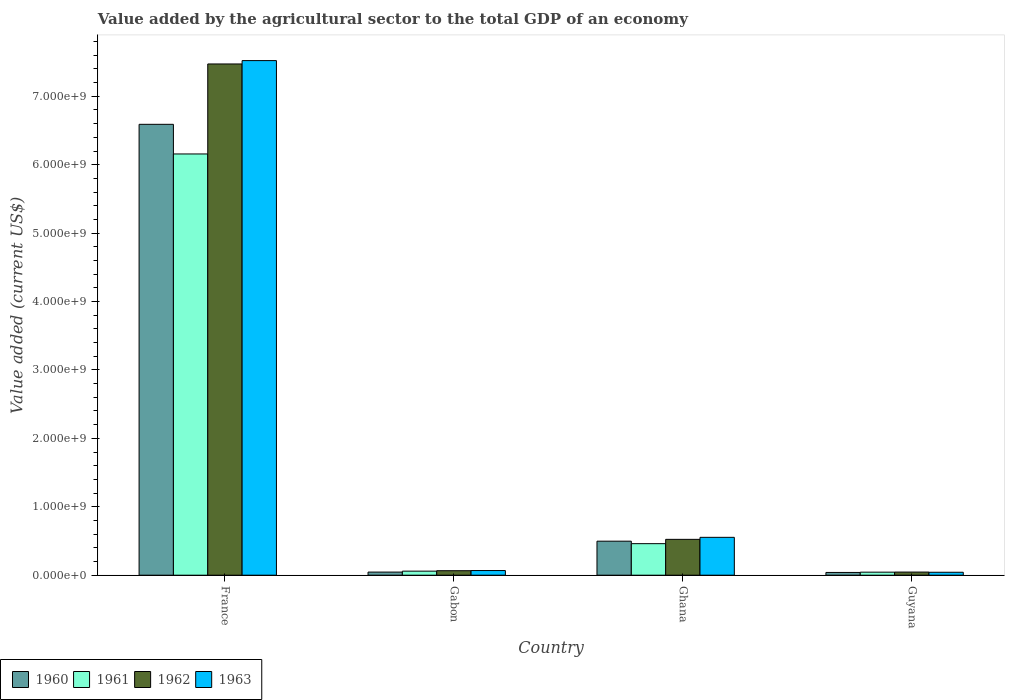Are the number of bars on each tick of the X-axis equal?
Offer a terse response. Yes. How many bars are there on the 3rd tick from the left?
Offer a terse response. 4. What is the label of the 2nd group of bars from the left?
Your answer should be very brief. Gabon. What is the value added by the agricultural sector to the total GDP in 1961 in Gabon?
Ensure brevity in your answer.  5.90e+07. Across all countries, what is the maximum value added by the agricultural sector to the total GDP in 1960?
Your response must be concise. 6.59e+09. Across all countries, what is the minimum value added by the agricultural sector to the total GDP in 1962?
Your response must be concise. 4.57e+07. In which country was the value added by the agricultural sector to the total GDP in 1961 maximum?
Your response must be concise. France. In which country was the value added by the agricultural sector to the total GDP in 1963 minimum?
Your response must be concise. Guyana. What is the total value added by the agricultural sector to the total GDP in 1960 in the graph?
Provide a short and direct response. 7.17e+09. What is the difference between the value added by the agricultural sector to the total GDP in 1961 in France and that in Guyana?
Offer a terse response. 6.11e+09. What is the difference between the value added by the agricultural sector to the total GDP in 1960 in France and the value added by the agricultural sector to the total GDP in 1963 in Ghana?
Offer a very short reply. 6.04e+09. What is the average value added by the agricultural sector to the total GDP in 1961 per country?
Your answer should be compact. 1.68e+09. What is the difference between the value added by the agricultural sector to the total GDP of/in 1962 and value added by the agricultural sector to the total GDP of/in 1960 in Gabon?
Your answer should be very brief. 2.01e+07. What is the ratio of the value added by the agricultural sector to the total GDP in 1961 in France to that in Ghana?
Provide a succinct answer. 13.36. What is the difference between the highest and the second highest value added by the agricultural sector to the total GDP in 1961?
Offer a terse response. 6.10e+09. What is the difference between the highest and the lowest value added by the agricultural sector to the total GDP in 1962?
Ensure brevity in your answer.  7.43e+09. Is the sum of the value added by the agricultural sector to the total GDP in 1961 in Ghana and Guyana greater than the maximum value added by the agricultural sector to the total GDP in 1960 across all countries?
Your answer should be very brief. No. Is it the case that in every country, the sum of the value added by the agricultural sector to the total GDP in 1961 and value added by the agricultural sector to the total GDP in 1963 is greater than the sum of value added by the agricultural sector to the total GDP in 1960 and value added by the agricultural sector to the total GDP in 1962?
Make the answer very short. No. What does the 3rd bar from the right in Gabon represents?
Ensure brevity in your answer.  1961. Is it the case that in every country, the sum of the value added by the agricultural sector to the total GDP in 1962 and value added by the agricultural sector to the total GDP in 1961 is greater than the value added by the agricultural sector to the total GDP in 1963?
Your response must be concise. Yes. How many countries are there in the graph?
Offer a terse response. 4. What is the difference between two consecutive major ticks on the Y-axis?
Your answer should be very brief. 1.00e+09. Does the graph contain grids?
Provide a short and direct response. No. Where does the legend appear in the graph?
Give a very brief answer. Bottom left. How many legend labels are there?
Your response must be concise. 4. What is the title of the graph?
Ensure brevity in your answer.  Value added by the agricultural sector to the total GDP of an economy. Does "2004" appear as one of the legend labels in the graph?
Give a very brief answer. No. What is the label or title of the X-axis?
Provide a short and direct response. Country. What is the label or title of the Y-axis?
Keep it short and to the point. Value added (current US$). What is the Value added (current US$) in 1960 in France?
Your response must be concise. 6.59e+09. What is the Value added (current US$) in 1961 in France?
Keep it short and to the point. 6.16e+09. What is the Value added (current US$) in 1962 in France?
Give a very brief answer. 7.47e+09. What is the Value added (current US$) of 1963 in France?
Offer a very short reply. 7.52e+09. What is the Value added (current US$) of 1960 in Gabon?
Your answer should be very brief. 4.55e+07. What is the Value added (current US$) of 1961 in Gabon?
Make the answer very short. 5.90e+07. What is the Value added (current US$) of 1962 in Gabon?
Your answer should be very brief. 6.56e+07. What is the Value added (current US$) of 1963 in Gabon?
Give a very brief answer. 6.81e+07. What is the Value added (current US$) in 1960 in Ghana?
Ensure brevity in your answer.  4.97e+08. What is the Value added (current US$) of 1961 in Ghana?
Keep it short and to the point. 4.61e+08. What is the Value added (current US$) in 1962 in Ghana?
Provide a short and direct response. 5.24e+08. What is the Value added (current US$) in 1963 in Ghana?
Your answer should be compact. 5.53e+08. What is the Value added (current US$) of 1960 in Guyana?
Offer a terse response. 4.01e+07. What is the Value added (current US$) of 1961 in Guyana?
Provide a short and direct response. 4.43e+07. What is the Value added (current US$) of 1962 in Guyana?
Your answer should be compact. 4.57e+07. What is the Value added (current US$) in 1963 in Guyana?
Provide a succinct answer. 4.30e+07. Across all countries, what is the maximum Value added (current US$) in 1960?
Give a very brief answer. 6.59e+09. Across all countries, what is the maximum Value added (current US$) of 1961?
Your answer should be very brief. 6.16e+09. Across all countries, what is the maximum Value added (current US$) in 1962?
Your answer should be very brief. 7.47e+09. Across all countries, what is the maximum Value added (current US$) in 1963?
Your answer should be compact. 7.52e+09. Across all countries, what is the minimum Value added (current US$) of 1960?
Your answer should be very brief. 4.01e+07. Across all countries, what is the minimum Value added (current US$) of 1961?
Offer a terse response. 4.43e+07. Across all countries, what is the minimum Value added (current US$) of 1962?
Provide a succinct answer. 4.57e+07. Across all countries, what is the minimum Value added (current US$) in 1963?
Your response must be concise. 4.30e+07. What is the total Value added (current US$) of 1960 in the graph?
Keep it short and to the point. 7.17e+09. What is the total Value added (current US$) in 1961 in the graph?
Your response must be concise. 6.72e+09. What is the total Value added (current US$) in 1962 in the graph?
Provide a short and direct response. 8.11e+09. What is the total Value added (current US$) of 1963 in the graph?
Offer a terse response. 8.19e+09. What is the difference between the Value added (current US$) of 1960 in France and that in Gabon?
Your answer should be compact. 6.54e+09. What is the difference between the Value added (current US$) in 1961 in France and that in Gabon?
Your answer should be compact. 6.10e+09. What is the difference between the Value added (current US$) in 1962 in France and that in Gabon?
Provide a short and direct response. 7.41e+09. What is the difference between the Value added (current US$) of 1963 in France and that in Gabon?
Provide a short and direct response. 7.45e+09. What is the difference between the Value added (current US$) of 1960 in France and that in Ghana?
Give a very brief answer. 6.09e+09. What is the difference between the Value added (current US$) in 1961 in France and that in Ghana?
Keep it short and to the point. 5.70e+09. What is the difference between the Value added (current US$) in 1962 in France and that in Ghana?
Ensure brevity in your answer.  6.95e+09. What is the difference between the Value added (current US$) of 1963 in France and that in Ghana?
Give a very brief answer. 6.97e+09. What is the difference between the Value added (current US$) in 1960 in France and that in Guyana?
Ensure brevity in your answer.  6.55e+09. What is the difference between the Value added (current US$) in 1961 in France and that in Guyana?
Make the answer very short. 6.11e+09. What is the difference between the Value added (current US$) of 1962 in France and that in Guyana?
Your answer should be compact. 7.43e+09. What is the difference between the Value added (current US$) of 1963 in France and that in Guyana?
Provide a succinct answer. 7.48e+09. What is the difference between the Value added (current US$) in 1960 in Gabon and that in Ghana?
Provide a succinct answer. -4.52e+08. What is the difference between the Value added (current US$) of 1961 in Gabon and that in Ghana?
Provide a succinct answer. -4.02e+08. What is the difference between the Value added (current US$) of 1962 in Gabon and that in Ghana?
Provide a succinct answer. -4.58e+08. What is the difference between the Value added (current US$) of 1963 in Gabon and that in Ghana?
Provide a succinct answer. -4.85e+08. What is the difference between the Value added (current US$) in 1960 in Gabon and that in Guyana?
Make the answer very short. 5.40e+06. What is the difference between the Value added (current US$) of 1961 in Gabon and that in Guyana?
Keep it short and to the point. 1.47e+07. What is the difference between the Value added (current US$) in 1962 in Gabon and that in Guyana?
Offer a very short reply. 1.99e+07. What is the difference between the Value added (current US$) in 1963 in Gabon and that in Guyana?
Ensure brevity in your answer.  2.51e+07. What is the difference between the Value added (current US$) in 1960 in Ghana and that in Guyana?
Offer a terse response. 4.57e+08. What is the difference between the Value added (current US$) of 1961 in Ghana and that in Guyana?
Give a very brief answer. 4.17e+08. What is the difference between the Value added (current US$) in 1962 in Ghana and that in Guyana?
Offer a very short reply. 4.78e+08. What is the difference between the Value added (current US$) in 1963 in Ghana and that in Guyana?
Keep it short and to the point. 5.10e+08. What is the difference between the Value added (current US$) of 1960 in France and the Value added (current US$) of 1961 in Gabon?
Offer a very short reply. 6.53e+09. What is the difference between the Value added (current US$) in 1960 in France and the Value added (current US$) in 1962 in Gabon?
Your answer should be compact. 6.52e+09. What is the difference between the Value added (current US$) in 1960 in France and the Value added (current US$) in 1963 in Gabon?
Provide a succinct answer. 6.52e+09. What is the difference between the Value added (current US$) of 1961 in France and the Value added (current US$) of 1962 in Gabon?
Give a very brief answer. 6.09e+09. What is the difference between the Value added (current US$) of 1961 in France and the Value added (current US$) of 1963 in Gabon?
Your response must be concise. 6.09e+09. What is the difference between the Value added (current US$) of 1962 in France and the Value added (current US$) of 1963 in Gabon?
Your answer should be very brief. 7.40e+09. What is the difference between the Value added (current US$) of 1960 in France and the Value added (current US$) of 1961 in Ghana?
Give a very brief answer. 6.13e+09. What is the difference between the Value added (current US$) of 1960 in France and the Value added (current US$) of 1962 in Ghana?
Keep it short and to the point. 6.07e+09. What is the difference between the Value added (current US$) of 1960 in France and the Value added (current US$) of 1963 in Ghana?
Your answer should be compact. 6.04e+09. What is the difference between the Value added (current US$) in 1961 in France and the Value added (current US$) in 1962 in Ghana?
Your response must be concise. 5.63e+09. What is the difference between the Value added (current US$) of 1961 in France and the Value added (current US$) of 1963 in Ghana?
Make the answer very short. 5.60e+09. What is the difference between the Value added (current US$) of 1962 in France and the Value added (current US$) of 1963 in Ghana?
Keep it short and to the point. 6.92e+09. What is the difference between the Value added (current US$) in 1960 in France and the Value added (current US$) in 1961 in Guyana?
Give a very brief answer. 6.55e+09. What is the difference between the Value added (current US$) of 1960 in France and the Value added (current US$) of 1962 in Guyana?
Provide a succinct answer. 6.54e+09. What is the difference between the Value added (current US$) in 1960 in France and the Value added (current US$) in 1963 in Guyana?
Your answer should be compact. 6.55e+09. What is the difference between the Value added (current US$) of 1961 in France and the Value added (current US$) of 1962 in Guyana?
Keep it short and to the point. 6.11e+09. What is the difference between the Value added (current US$) in 1961 in France and the Value added (current US$) in 1963 in Guyana?
Your answer should be compact. 6.11e+09. What is the difference between the Value added (current US$) in 1962 in France and the Value added (current US$) in 1963 in Guyana?
Keep it short and to the point. 7.43e+09. What is the difference between the Value added (current US$) of 1960 in Gabon and the Value added (current US$) of 1961 in Ghana?
Give a very brief answer. -4.15e+08. What is the difference between the Value added (current US$) of 1960 in Gabon and the Value added (current US$) of 1962 in Ghana?
Offer a terse response. -4.78e+08. What is the difference between the Value added (current US$) in 1960 in Gabon and the Value added (current US$) in 1963 in Ghana?
Make the answer very short. -5.08e+08. What is the difference between the Value added (current US$) of 1961 in Gabon and the Value added (current US$) of 1962 in Ghana?
Your answer should be very brief. -4.65e+08. What is the difference between the Value added (current US$) of 1961 in Gabon and the Value added (current US$) of 1963 in Ghana?
Provide a short and direct response. -4.94e+08. What is the difference between the Value added (current US$) in 1962 in Gabon and the Value added (current US$) in 1963 in Ghana?
Offer a very short reply. -4.88e+08. What is the difference between the Value added (current US$) of 1960 in Gabon and the Value added (current US$) of 1961 in Guyana?
Ensure brevity in your answer.  1.20e+06. What is the difference between the Value added (current US$) of 1960 in Gabon and the Value added (current US$) of 1962 in Guyana?
Give a very brief answer. -1.99e+05. What is the difference between the Value added (current US$) in 1960 in Gabon and the Value added (current US$) in 1963 in Guyana?
Offer a terse response. 2.54e+06. What is the difference between the Value added (current US$) in 1961 in Gabon and the Value added (current US$) in 1962 in Guyana?
Offer a terse response. 1.33e+07. What is the difference between the Value added (current US$) in 1961 in Gabon and the Value added (current US$) in 1963 in Guyana?
Your answer should be very brief. 1.60e+07. What is the difference between the Value added (current US$) in 1962 in Gabon and the Value added (current US$) in 1963 in Guyana?
Your answer should be compact. 2.26e+07. What is the difference between the Value added (current US$) in 1960 in Ghana and the Value added (current US$) in 1961 in Guyana?
Give a very brief answer. 4.53e+08. What is the difference between the Value added (current US$) in 1960 in Ghana and the Value added (current US$) in 1962 in Guyana?
Your response must be concise. 4.52e+08. What is the difference between the Value added (current US$) of 1960 in Ghana and the Value added (current US$) of 1963 in Guyana?
Give a very brief answer. 4.54e+08. What is the difference between the Value added (current US$) of 1961 in Ghana and the Value added (current US$) of 1962 in Guyana?
Your response must be concise. 4.15e+08. What is the difference between the Value added (current US$) of 1961 in Ghana and the Value added (current US$) of 1963 in Guyana?
Your answer should be compact. 4.18e+08. What is the difference between the Value added (current US$) in 1962 in Ghana and the Value added (current US$) in 1963 in Guyana?
Keep it short and to the point. 4.81e+08. What is the average Value added (current US$) of 1960 per country?
Your answer should be very brief. 1.79e+09. What is the average Value added (current US$) in 1961 per country?
Ensure brevity in your answer.  1.68e+09. What is the average Value added (current US$) of 1962 per country?
Your response must be concise. 2.03e+09. What is the average Value added (current US$) in 1963 per country?
Offer a very short reply. 2.05e+09. What is the difference between the Value added (current US$) of 1960 and Value added (current US$) of 1961 in France?
Your answer should be very brief. 4.33e+08. What is the difference between the Value added (current US$) in 1960 and Value added (current US$) in 1962 in France?
Keep it short and to the point. -8.82e+08. What is the difference between the Value added (current US$) in 1960 and Value added (current US$) in 1963 in France?
Your answer should be very brief. -9.31e+08. What is the difference between the Value added (current US$) of 1961 and Value added (current US$) of 1962 in France?
Give a very brief answer. -1.32e+09. What is the difference between the Value added (current US$) in 1961 and Value added (current US$) in 1963 in France?
Your answer should be compact. -1.36e+09. What is the difference between the Value added (current US$) of 1962 and Value added (current US$) of 1963 in France?
Your answer should be very brief. -4.92e+07. What is the difference between the Value added (current US$) of 1960 and Value added (current US$) of 1961 in Gabon?
Ensure brevity in your answer.  -1.35e+07. What is the difference between the Value added (current US$) in 1960 and Value added (current US$) in 1962 in Gabon?
Your answer should be compact. -2.01e+07. What is the difference between the Value added (current US$) of 1960 and Value added (current US$) of 1963 in Gabon?
Provide a succinct answer. -2.26e+07. What is the difference between the Value added (current US$) of 1961 and Value added (current US$) of 1962 in Gabon?
Your answer should be very brief. -6.57e+06. What is the difference between the Value added (current US$) in 1961 and Value added (current US$) in 1963 in Gabon?
Give a very brief answer. -9.07e+06. What is the difference between the Value added (current US$) in 1962 and Value added (current US$) in 1963 in Gabon?
Make the answer very short. -2.50e+06. What is the difference between the Value added (current US$) of 1960 and Value added (current US$) of 1961 in Ghana?
Your answer should be very brief. 3.64e+07. What is the difference between the Value added (current US$) of 1960 and Value added (current US$) of 1962 in Ghana?
Give a very brief answer. -2.66e+07. What is the difference between the Value added (current US$) in 1960 and Value added (current US$) in 1963 in Ghana?
Offer a very short reply. -5.60e+07. What is the difference between the Value added (current US$) in 1961 and Value added (current US$) in 1962 in Ghana?
Ensure brevity in your answer.  -6.30e+07. What is the difference between the Value added (current US$) of 1961 and Value added (current US$) of 1963 in Ghana?
Offer a terse response. -9.24e+07. What is the difference between the Value added (current US$) in 1962 and Value added (current US$) in 1963 in Ghana?
Provide a short and direct response. -2.94e+07. What is the difference between the Value added (current US$) of 1960 and Value added (current US$) of 1961 in Guyana?
Ensure brevity in your answer.  -4.20e+06. What is the difference between the Value added (current US$) in 1960 and Value added (current US$) in 1962 in Guyana?
Keep it short and to the point. -5.60e+06. What is the difference between the Value added (current US$) in 1960 and Value added (current US$) in 1963 in Guyana?
Your answer should be compact. -2.86e+06. What is the difference between the Value added (current US$) of 1961 and Value added (current US$) of 1962 in Guyana?
Make the answer very short. -1.40e+06. What is the difference between the Value added (current US$) in 1961 and Value added (current US$) in 1963 in Guyana?
Offer a terse response. 1.34e+06. What is the difference between the Value added (current US$) in 1962 and Value added (current US$) in 1963 in Guyana?
Provide a succinct answer. 2.74e+06. What is the ratio of the Value added (current US$) of 1960 in France to that in Gabon?
Your response must be concise. 144.73. What is the ratio of the Value added (current US$) in 1961 in France to that in Gabon?
Keep it short and to the point. 104.3. What is the ratio of the Value added (current US$) in 1962 in France to that in Gabon?
Provide a succinct answer. 113.91. What is the ratio of the Value added (current US$) of 1963 in France to that in Gabon?
Give a very brief answer. 110.45. What is the ratio of the Value added (current US$) of 1960 in France to that in Ghana?
Offer a very short reply. 13.25. What is the ratio of the Value added (current US$) in 1961 in France to that in Ghana?
Ensure brevity in your answer.  13.36. What is the ratio of the Value added (current US$) of 1962 in France to that in Ghana?
Offer a very short reply. 14.26. What is the ratio of the Value added (current US$) in 1963 in France to that in Ghana?
Provide a short and direct response. 13.59. What is the ratio of the Value added (current US$) of 1960 in France to that in Guyana?
Provide a succinct answer. 164.2. What is the ratio of the Value added (current US$) of 1961 in France to that in Guyana?
Make the answer very short. 138.88. What is the ratio of the Value added (current US$) in 1962 in France to that in Guyana?
Your answer should be compact. 163.39. What is the ratio of the Value added (current US$) in 1963 in France to that in Guyana?
Offer a terse response. 174.95. What is the ratio of the Value added (current US$) in 1960 in Gabon to that in Ghana?
Make the answer very short. 0.09. What is the ratio of the Value added (current US$) in 1961 in Gabon to that in Ghana?
Your answer should be very brief. 0.13. What is the ratio of the Value added (current US$) of 1962 in Gabon to that in Ghana?
Make the answer very short. 0.13. What is the ratio of the Value added (current US$) in 1963 in Gabon to that in Ghana?
Your response must be concise. 0.12. What is the ratio of the Value added (current US$) of 1960 in Gabon to that in Guyana?
Your answer should be very brief. 1.13. What is the ratio of the Value added (current US$) in 1961 in Gabon to that in Guyana?
Ensure brevity in your answer.  1.33. What is the ratio of the Value added (current US$) in 1962 in Gabon to that in Guyana?
Your response must be concise. 1.43. What is the ratio of the Value added (current US$) of 1963 in Gabon to that in Guyana?
Keep it short and to the point. 1.58. What is the ratio of the Value added (current US$) in 1960 in Ghana to that in Guyana?
Offer a very short reply. 12.39. What is the ratio of the Value added (current US$) of 1961 in Ghana to that in Guyana?
Offer a terse response. 10.39. What is the ratio of the Value added (current US$) in 1962 in Ghana to that in Guyana?
Your answer should be compact. 11.45. What is the ratio of the Value added (current US$) in 1963 in Ghana to that in Guyana?
Provide a short and direct response. 12.87. What is the difference between the highest and the second highest Value added (current US$) in 1960?
Provide a succinct answer. 6.09e+09. What is the difference between the highest and the second highest Value added (current US$) of 1961?
Ensure brevity in your answer.  5.70e+09. What is the difference between the highest and the second highest Value added (current US$) in 1962?
Your answer should be compact. 6.95e+09. What is the difference between the highest and the second highest Value added (current US$) in 1963?
Make the answer very short. 6.97e+09. What is the difference between the highest and the lowest Value added (current US$) in 1960?
Ensure brevity in your answer.  6.55e+09. What is the difference between the highest and the lowest Value added (current US$) of 1961?
Keep it short and to the point. 6.11e+09. What is the difference between the highest and the lowest Value added (current US$) in 1962?
Ensure brevity in your answer.  7.43e+09. What is the difference between the highest and the lowest Value added (current US$) of 1963?
Offer a terse response. 7.48e+09. 